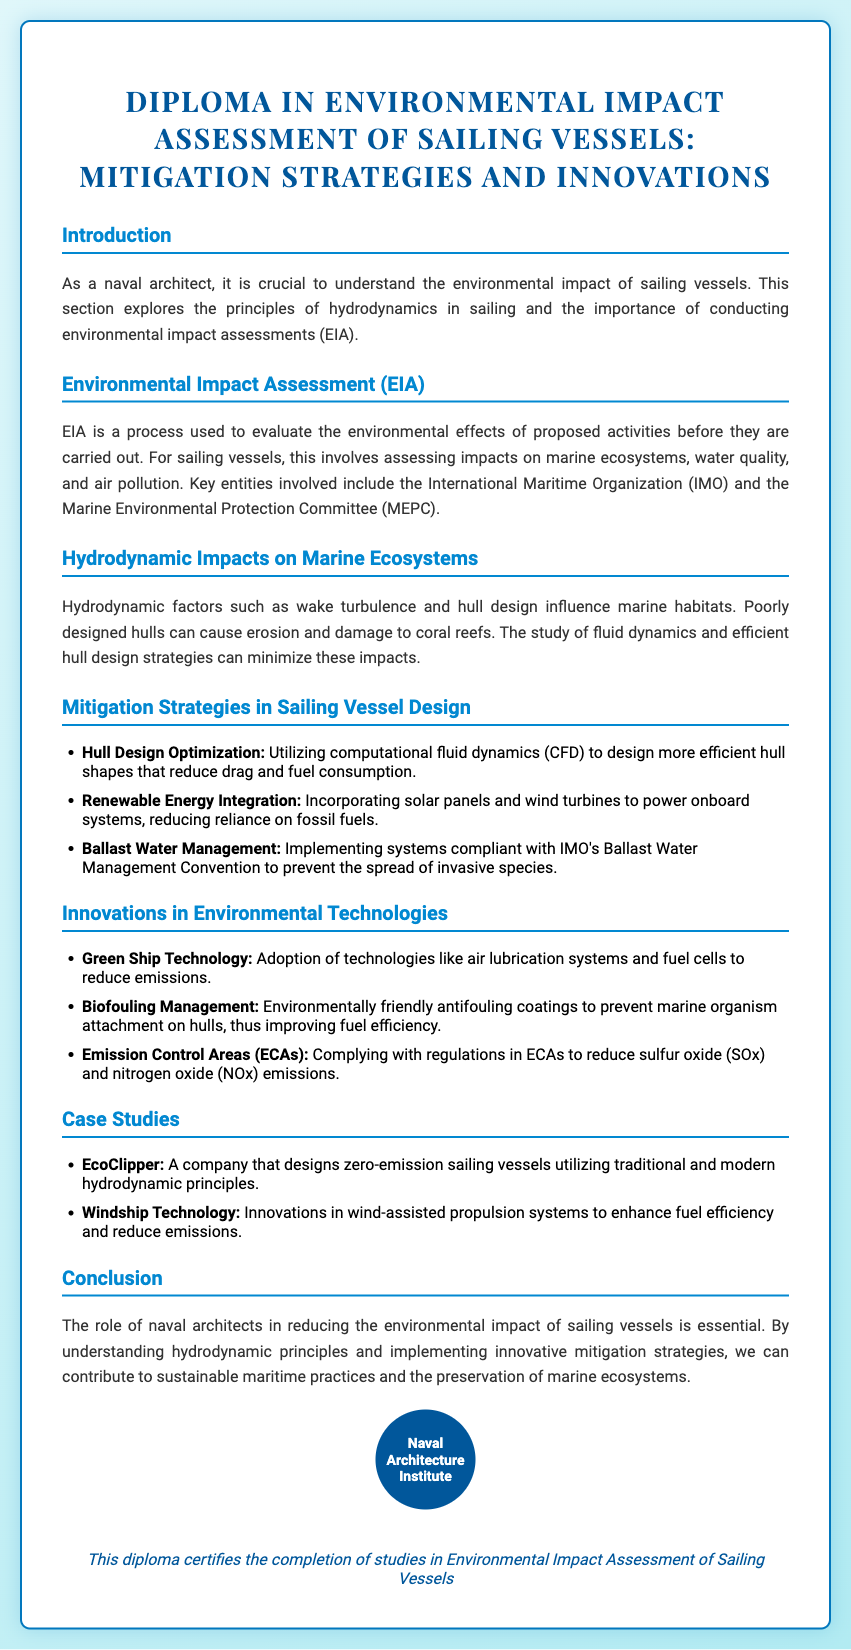what is the title of the diploma? The title of the diploma is clearly stated at the top of the document.
Answer: Diploma in Environmental Impact Assessment of Sailing Vessels: Mitigation Strategies and Innovations what organization is mentioned for ballast water management? The document refers to a specific organization involved in ballast water management, which is a key aspect of environmental assessment.
Answer: International Maritime Organization (IMO) what is the main focus of the hydrodynamic impacts section? The section discusses the effects of hydrodynamic factors on marine habitats, emphasizing the importance of design.
Answer: Marine ecosystems how many innovations in environmental technologies are listed? The document contains a specific number of innovations related to environmental technologies.
Answer: Three name one mitigation strategy mentioned for sailing vessel design. A specific mitigation strategy is provided, highlighting approaches to reduce environmental impact.
Answer: Hull Design Optimization which company is noted for designing zero-emission sailing vessels? The document cites a company as a case study for its contributions to sailing vessel design.
Answer: EcoClipper what is a requirement in Emission Control Areas (ECAs)? The document specifies compliance involving emissions in regulated areas.
Answer: Reduce sulfur oxide (SOx) and nitrogen oxide (NOx) what is the primary role of naval architects as stated in the conclusion? The conclusion emphasizes a specific responsibility of naval architects in the context of environmental impact.
Answer: Reducing environmental impact how does the document classify the types of questions it addresses? It categorizes the content into various sections relevant to the field of naval architecture.
Answer: Short-answer questions 